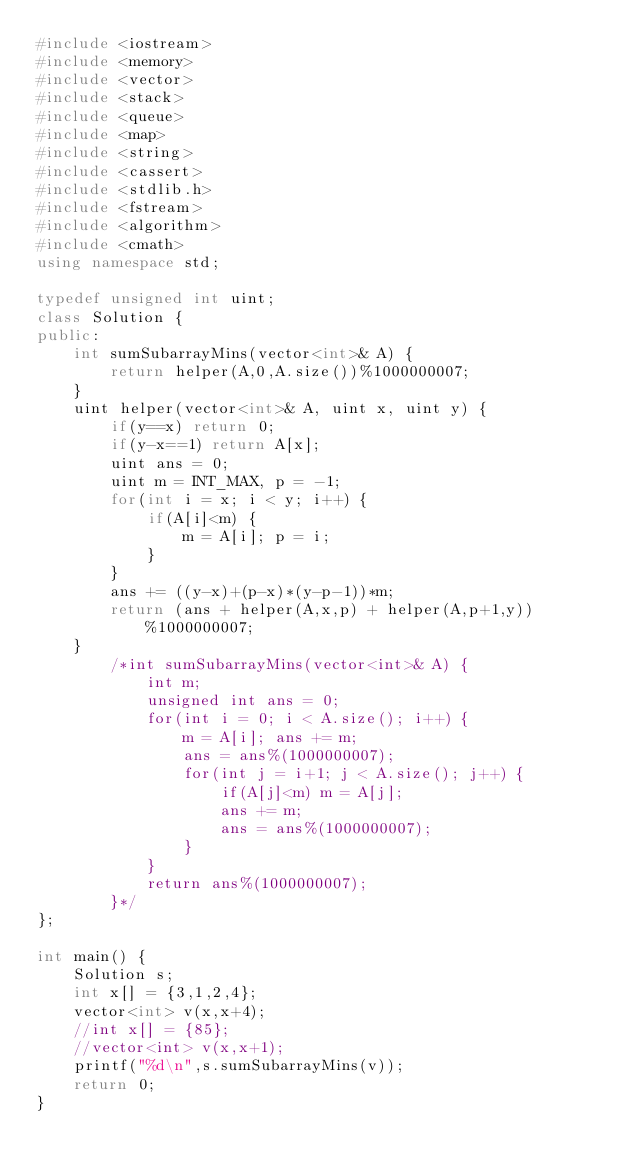<code> <loc_0><loc_0><loc_500><loc_500><_C++_>#include <iostream>
#include <memory>
#include <vector>
#include <stack>
#include <queue>
#include <map>
#include <string>
#include <cassert>
#include <stdlib.h>
#include <fstream>
#include <algorithm>
#include <cmath>
using namespace std;

typedef unsigned int uint;
class Solution {
public:
    int sumSubarrayMins(vector<int>& A) {
        return helper(A,0,A.size())%1000000007;
    }
    uint helper(vector<int>& A, uint x, uint y) {
        if(y==x) return 0;
        if(y-x==1) return A[x];
        uint ans = 0;
        uint m = INT_MAX, p = -1;
        for(int i = x; i < y; i++) {
            if(A[i]<m) {
                m = A[i]; p = i;
            }
        }
        ans += ((y-x)+(p-x)*(y-p-1))*m;
        return (ans + helper(A,x,p) + helper(A,p+1,y))%1000000007;
    }
        /*int sumSubarrayMins(vector<int>& A) {
            int m;
            unsigned int ans = 0;
            for(int i = 0; i < A.size(); i++) {
                m = A[i]; ans += m;
                ans = ans%(1000000007);
                for(int j = i+1; j < A.size(); j++) {
                    if(A[j]<m) m = A[j];
                    ans += m;
                    ans = ans%(1000000007);
                }
            }
            return ans%(1000000007);
        }*/
};

int main() {
    Solution s;
    int x[] = {3,1,2,4};
    vector<int> v(x,x+4);
    //int x[] = {85};
    //vector<int> v(x,x+1);
    printf("%d\n",s.sumSubarrayMins(v));
    return 0;
}</code> 